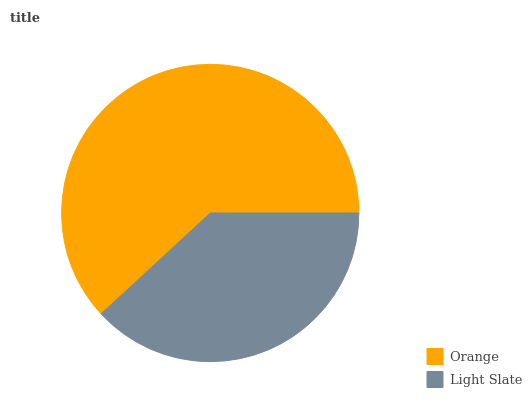Is Light Slate the minimum?
Answer yes or no. Yes. Is Orange the maximum?
Answer yes or no. Yes. Is Light Slate the maximum?
Answer yes or no. No. Is Orange greater than Light Slate?
Answer yes or no. Yes. Is Light Slate less than Orange?
Answer yes or no. Yes. Is Light Slate greater than Orange?
Answer yes or no. No. Is Orange less than Light Slate?
Answer yes or no. No. Is Orange the high median?
Answer yes or no. Yes. Is Light Slate the low median?
Answer yes or no. Yes. Is Light Slate the high median?
Answer yes or no. No. Is Orange the low median?
Answer yes or no. No. 